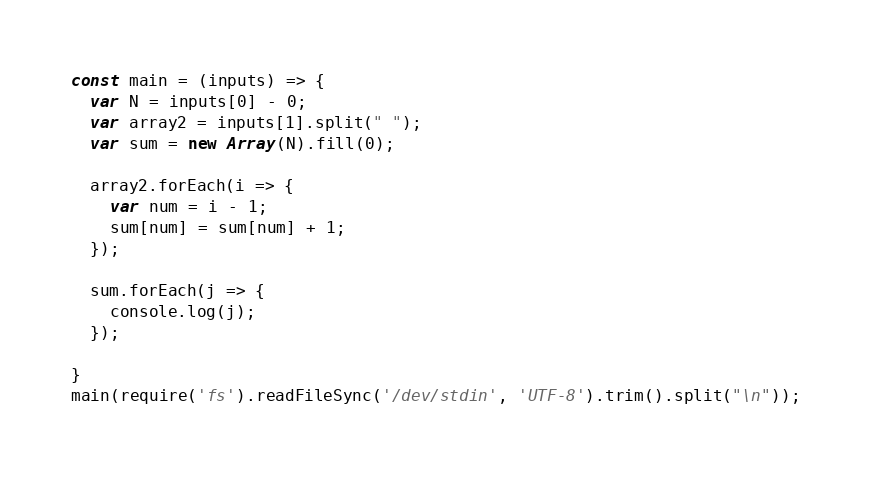Convert code to text. <code><loc_0><loc_0><loc_500><loc_500><_JavaScript_>const main = (inputs) => {
  var N = inputs[0] - 0;
  var array2 = inputs[1].split(" ");
  var sum = new Array(N).fill(0);

  array2.forEach(i => {
    var num = i - 1;
    sum[num] = sum[num] + 1;
  });

  sum.forEach(j => {
    console.log(j);
  });

}
main(require('fs').readFileSync('/dev/stdin', 'UTF-8').trim().split("\n"));</code> 